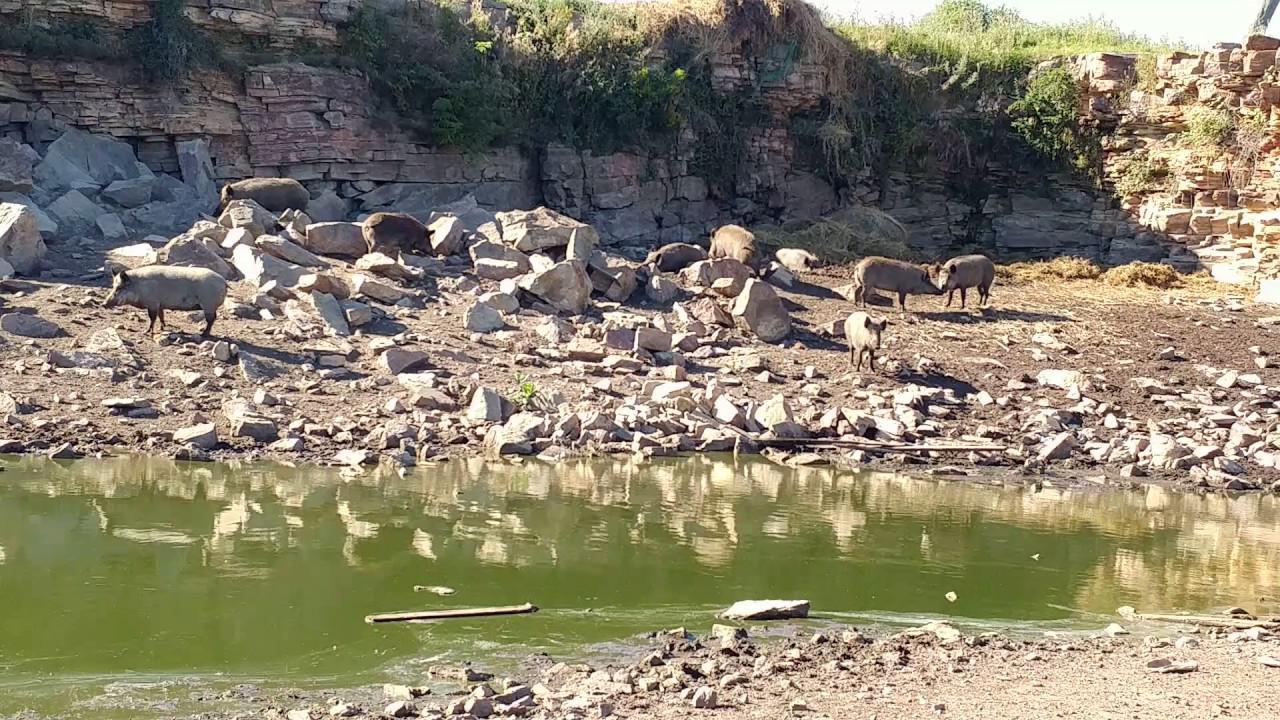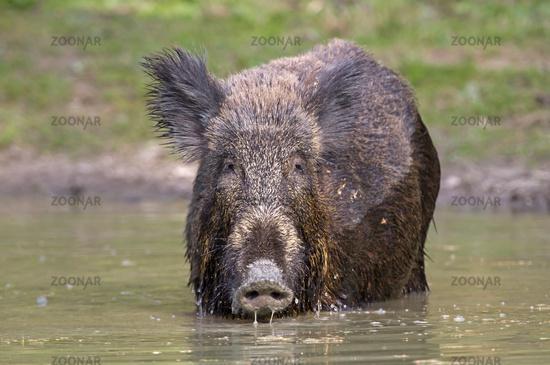The first image is the image on the left, the second image is the image on the right. Considering the images on both sides, is "One image shows a single forward-facing wild pig standing in an area that is not covered in water, and the other image shows at least one pig in water." valid? Answer yes or no. No. The first image is the image on the left, the second image is the image on the right. For the images shown, is this caption "In at least one image there is a single boar facing right in the water next to the grassy bank." true? Answer yes or no. No. 